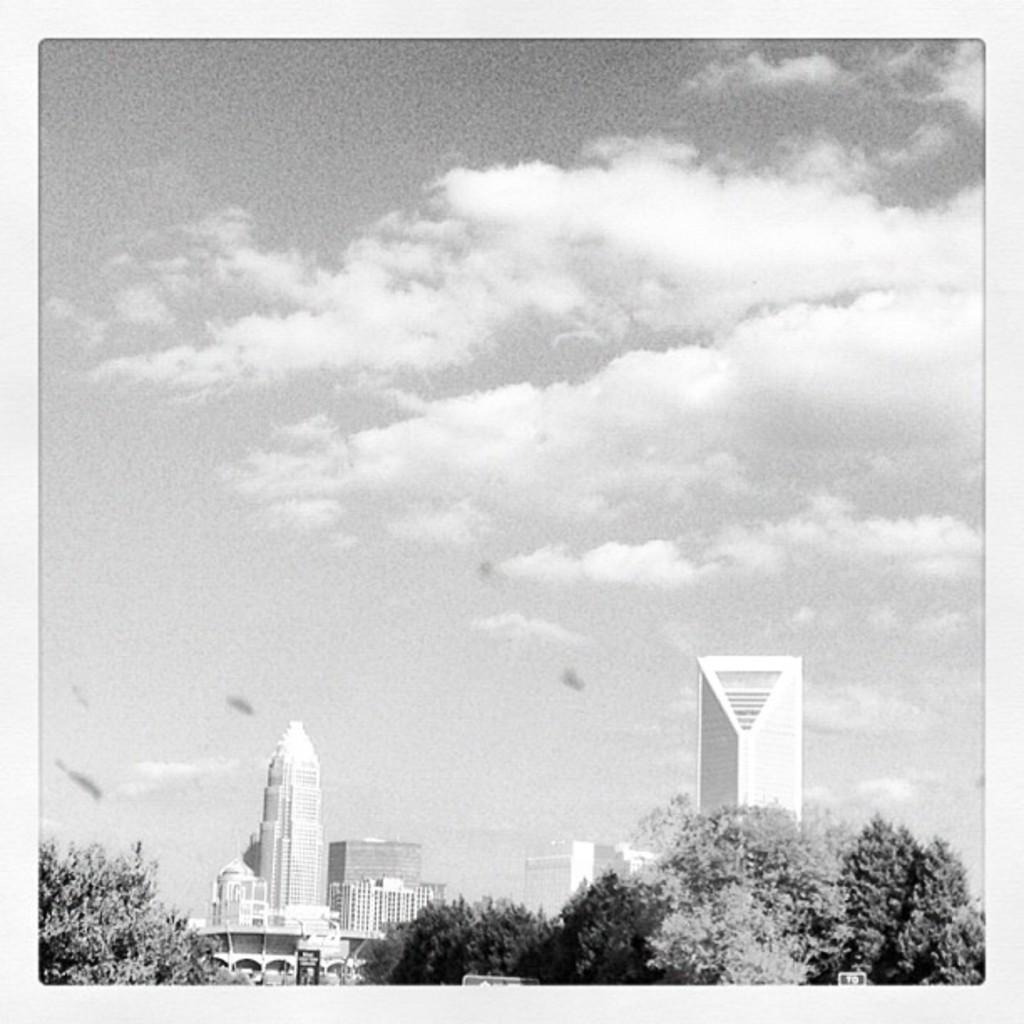Please provide a concise description of this image. At the bottom of the image there are some buildings and trees. In the background there is a sky. 